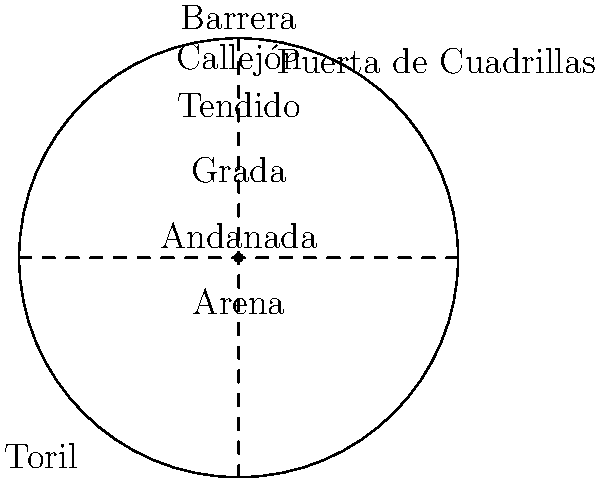In a typical bullring layout, which area is located closest to the arena and serves as a protective barrier for the matadors? To answer this question, let's examine the layout of a typical bullring from the center outwards:

1. The central area is called the "Arena," where the actual bullfight takes place.

2. Moving outward from the arena, we encounter the first barrier, which is called the "Barrera." This is a wooden fence that encircles the arena.

3. Just behind the barrera is a narrow circular corridor called the "Callejón." This area serves as a refuge for matadors and other bullfighting participants.

4. Beyond the callejón are the spectator areas, starting with the "Tendido," which are the lower seats closest to the action.

5. Above the tendido are the "Grada" and "Andanada," which are higher seating areas.

Given this layout, the area closest to the arena that serves as a protective barrier for the matadors is the "Barrera." It's the first line of defense between the bull and the participants, allowing them to quickly jump over it into the callejón for safety if needed.
Answer: Barrera 